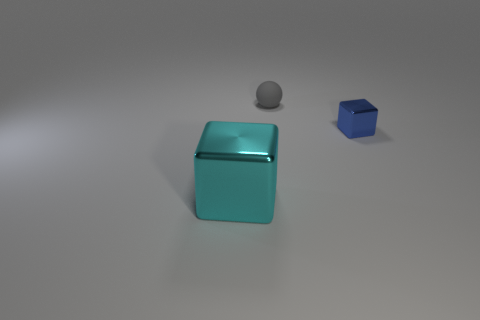Subtract all cyan cubes. How many cubes are left? 1 Subtract all blocks. How many objects are left? 1 Subtract 1 blocks. How many blocks are left? 1 Add 1 large blue blocks. How many objects exist? 4 Add 3 small balls. How many small balls exist? 4 Subtract 1 cyan blocks. How many objects are left? 2 Subtract all purple balls. Subtract all cyan cylinders. How many balls are left? 1 Subtract all purple blocks. How many purple balls are left? 0 Subtract all small shiny things. Subtract all metallic cubes. How many objects are left? 0 Add 3 tiny objects. How many tiny objects are left? 5 